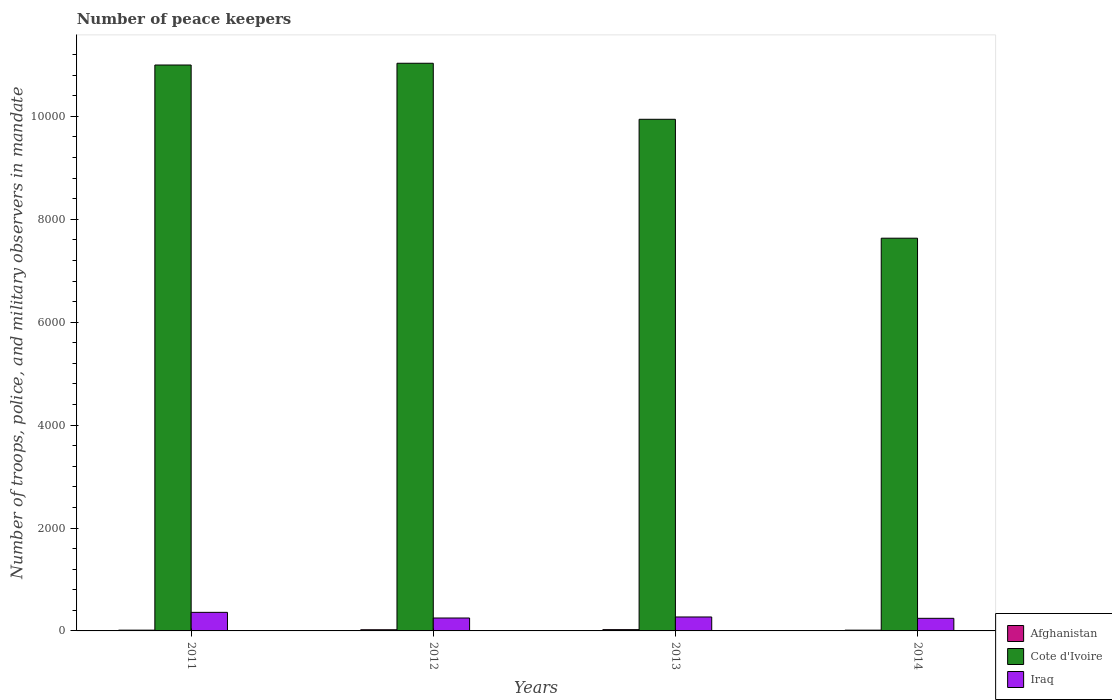How many different coloured bars are there?
Provide a succinct answer. 3. Are the number of bars per tick equal to the number of legend labels?
Your response must be concise. Yes. How many bars are there on the 3rd tick from the left?
Give a very brief answer. 3. How many bars are there on the 3rd tick from the right?
Give a very brief answer. 3. What is the number of peace keepers in in Cote d'Ivoire in 2012?
Make the answer very short. 1.10e+04. Across all years, what is the maximum number of peace keepers in in Afghanistan?
Provide a short and direct response. 25. Across all years, what is the minimum number of peace keepers in in Cote d'Ivoire?
Offer a very short reply. 7633. In which year was the number of peace keepers in in Iraq minimum?
Make the answer very short. 2014. What is the total number of peace keepers in in Cote d'Ivoire in the graph?
Offer a very short reply. 3.96e+04. What is the difference between the number of peace keepers in in Afghanistan in 2011 and that in 2012?
Give a very brief answer. -8. What is the difference between the number of peace keepers in in Afghanistan in 2011 and the number of peace keepers in in Iraq in 2013?
Your response must be concise. -256. In the year 2013, what is the difference between the number of peace keepers in in Iraq and number of peace keepers in in Afghanistan?
Offer a terse response. 246. What is the ratio of the number of peace keepers in in Cote d'Ivoire in 2011 to that in 2012?
Your answer should be very brief. 1. Is the number of peace keepers in in Cote d'Ivoire in 2013 less than that in 2014?
Keep it short and to the point. No. What is the difference between the highest and the second highest number of peace keepers in in Iraq?
Keep it short and to the point. 90. In how many years, is the number of peace keepers in in Cote d'Ivoire greater than the average number of peace keepers in in Cote d'Ivoire taken over all years?
Ensure brevity in your answer.  3. What does the 3rd bar from the left in 2013 represents?
Offer a very short reply. Iraq. What does the 2nd bar from the right in 2011 represents?
Offer a terse response. Cote d'Ivoire. Are all the bars in the graph horizontal?
Your answer should be very brief. No. Are the values on the major ticks of Y-axis written in scientific E-notation?
Keep it short and to the point. No. Does the graph contain any zero values?
Make the answer very short. No. Does the graph contain grids?
Your answer should be compact. No. How many legend labels are there?
Offer a terse response. 3. How are the legend labels stacked?
Ensure brevity in your answer.  Vertical. What is the title of the graph?
Ensure brevity in your answer.  Number of peace keepers. What is the label or title of the X-axis?
Keep it short and to the point. Years. What is the label or title of the Y-axis?
Make the answer very short. Number of troops, police, and military observers in mandate. What is the Number of troops, police, and military observers in mandate of Afghanistan in 2011?
Your answer should be very brief. 15. What is the Number of troops, police, and military observers in mandate in Cote d'Ivoire in 2011?
Provide a succinct answer. 1.10e+04. What is the Number of troops, police, and military observers in mandate of Iraq in 2011?
Give a very brief answer. 361. What is the Number of troops, police, and military observers in mandate of Cote d'Ivoire in 2012?
Offer a terse response. 1.10e+04. What is the Number of troops, police, and military observers in mandate in Iraq in 2012?
Give a very brief answer. 251. What is the Number of troops, police, and military observers in mandate in Cote d'Ivoire in 2013?
Offer a very short reply. 9944. What is the Number of troops, police, and military observers in mandate of Iraq in 2013?
Offer a very short reply. 271. What is the Number of troops, police, and military observers in mandate of Cote d'Ivoire in 2014?
Give a very brief answer. 7633. What is the Number of troops, police, and military observers in mandate of Iraq in 2014?
Your answer should be compact. 245. Across all years, what is the maximum Number of troops, police, and military observers in mandate of Cote d'Ivoire?
Offer a very short reply. 1.10e+04. Across all years, what is the maximum Number of troops, police, and military observers in mandate in Iraq?
Your answer should be very brief. 361. Across all years, what is the minimum Number of troops, police, and military observers in mandate of Afghanistan?
Make the answer very short. 15. Across all years, what is the minimum Number of troops, police, and military observers in mandate in Cote d'Ivoire?
Your response must be concise. 7633. Across all years, what is the minimum Number of troops, police, and military observers in mandate of Iraq?
Your answer should be compact. 245. What is the total Number of troops, police, and military observers in mandate of Cote d'Ivoire in the graph?
Ensure brevity in your answer.  3.96e+04. What is the total Number of troops, police, and military observers in mandate in Iraq in the graph?
Offer a terse response. 1128. What is the difference between the Number of troops, police, and military observers in mandate in Afghanistan in 2011 and that in 2012?
Make the answer very short. -8. What is the difference between the Number of troops, police, and military observers in mandate in Cote d'Ivoire in 2011 and that in 2012?
Your answer should be compact. -34. What is the difference between the Number of troops, police, and military observers in mandate of Iraq in 2011 and that in 2012?
Keep it short and to the point. 110. What is the difference between the Number of troops, police, and military observers in mandate in Cote d'Ivoire in 2011 and that in 2013?
Keep it short and to the point. 1055. What is the difference between the Number of troops, police, and military observers in mandate in Cote d'Ivoire in 2011 and that in 2014?
Provide a short and direct response. 3366. What is the difference between the Number of troops, police, and military observers in mandate in Iraq in 2011 and that in 2014?
Your answer should be very brief. 116. What is the difference between the Number of troops, police, and military observers in mandate of Afghanistan in 2012 and that in 2013?
Offer a very short reply. -2. What is the difference between the Number of troops, police, and military observers in mandate in Cote d'Ivoire in 2012 and that in 2013?
Offer a terse response. 1089. What is the difference between the Number of troops, police, and military observers in mandate of Afghanistan in 2012 and that in 2014?
Ensure brevity in your answer.  8. What is the difference between the Number of troops, police, and military observers in mandate of Cote d'Ivoire in 2012 and that in 2014?
Provide a short and direct response. 3400. What is the difference between the Number of troops, police, and military observers in mandate of Iraq in 2012 and that in 2014?
Provide a succinct answer. 6. What is the difference between the Number of troops, police, and military observers in mandate in Afghanistan in 2013 and that in 2014?
Your answer should be very brief. 10. What is the difference between the Number of troops, police, and military observers in mandate in Cote d'Ivoire in 2013 and that in 2014?
Ensure brevity in your answer.  2311. What is the difference between the Number of troops, police, and military observers in mandate of Iraq in 2013 and that in 2014?
Make the answer very short. 26. What is the difference between the Number of troops, police, and military observers in mandate of Afghanistan in 2011 and the Number of troops, police, and military observers in mandate of Cote d'Ivoire in 2012?
Your response must be concise. -1.10e+04. What is the difference between the Number of troops, police, and military observers in mandate in Afghanistan in 2011 and the Number of troops, police, and military observers in mandate in Iraq in 2012?
Keep it short and to the point. -236. What is the difference between the Number of troops, police, and military observers in mandate of Cote d'Ivoire in 2011 and the Number of troops, police, and military observers in mandate of Iraq in 2012?
Your answer should be compact. 1.07e+04. What is the difference between the Number of troops, police, and military observers in mandate in Afghanistan in 2011 and the Number of troops, police, and military observers in mandate in Cote d'Ivoire in 2013?
Make the answer very short. -9929. What is the difference between the Number of troops, police, and military observers in mandate of Afghanistan in 2011 and the Number of troops, police, and military observers in mandate of Iraq in 2013?
Keep it short and to the point. -256. What is the difference between the Number of troops, police, and military observers in mandate in Cote d'Ivoire in 2011 and the Number of troops, police, and military observers in mandate in Iraq in 2013?
Make the answer very short. 1.07e+04. What is the difference between the Number of troops, police, and military observers in mandate in Afghanistan in 2011 and the Number of troops, police, and military observers in mandate in Cote d'Ivoire in 2014?
Your response must be concise. -7618. What is the difference between the Number of troops, police, and military observers in mandate in Afghanistan in 2011 and the Number of troops, police, and military observers in mandate in Iraq in 2014?
Your answer should be very brief. -230. What is the difference between the Number of troops, police, and military observers in mandate of Cote d'Ivoire in 2011 and the Number of troops, police, and military observers in mandate of Iraq in 2014?
Give a very brief answer. 1.08e+04. What is the difference between the Number of troops, police, and military observers in mandate in Afghanistan in 2012 and the Number of troops, police, and military observers in mandate in Cote d'Ivoire in 2013?
Ensure brevity in your answer.  -9921. What is the difference between the Number of troops, police, and military observers in mandate of Afghanistan in 2012 and the Number of troops, police, and military observers in mandate of Iraq in 2013?
Keep it short and to the point. -248. What is the difference between the Number of troops, police, and military observers in mandate of Cote d'Ivoire in 2012 and the Number of troops, police, and military observers in mandate of Iraq in 2013?
Ensure brevity in your answer.  1.08e+04. What is the difference between the Number of troops, police, and military observers in mandate in Afghanistan in 2012 and the Number of troops, police, and military observers in mandate in Cote d'Ivoire in 2014?
Offer a terse response. -7610. What is the difference between the Number of troops, police, and military observers in mandate of Afghanistan in 2012 and the Number of troops, police, and military observers in mandate of Iraq in 2014?
Make the answer very short. -222. What is the difference between the Number of troops, police, and military observers in mandate of Cote d'Ivoire in 2012 and the Number of troops, police, and military observers in mandate of Iraq in 2014?
Make the answer very short. 1.08e+04. What is the difference between the Number of troops, police, and military observers in mandate in Afghanistan in 2013 and the Number of troops, police, and military observers in mandate in Cote d'Ivoire in 2014?
Offer a very short reply. -7608. What is the difference between the Number of troops, police, and military observers in mandate in Afghanistan in 2013 and the Number of troops, police, and military observers in mandate in Iraq in 2014?
Provide a succinct answer. -220. What is the difference between the Number of troops, police, and military observers in mandate in Cote d'Ivoire in 2013 and the Number of troops, police, and military observers in mandate in Iraq in 2014?
Offer a very short reply. 9699. What is the average Number of troops, police, and military observers in mandate of Afghanistan per year?
Provide a short and direct response. 19.5. What is the average Number of troops, police, and military observers in mandate of Cote d'Ivoire per year?
Give a very brief answer. 9902.25. What is the average Number of troops, police, and military observers in mandate of Iraq per year?
Ensure brevity in your answer.  282. In the year 2011, what is the difference between the Number of troops, police, and military observers in mandate in Afghanistan and Number of troops, police, and military observers in mandate in Cote d'Ivoire?
Offer a terse response. -1.10e+04. In the year 2011, what is the difference between the Number of troops, police, and military observers in mandate of Afghanistan and Number of troops, police, and military observers in mandate of Iraq?
Give a very brief answer. -346. In the year 2011, what is the difference between the Number of troops, police, and military observers in mandate of Cote d'Ivoire and Number of troops, police, and military observers in mandate of Iraq?
Your response must be concise. 1.06e+04. In the year 2012, what is the difference between the Number of troops, police, and military observers in mandate of Afghanistan and Number of troops, police, and military observers in mandate of Cote d'Ivoire?
Offer a very short reply. -1.10e+04. In the year 2012, what is the difference between the Number of troops, police, and military observers in mandate in Afghanistan and Number of troops, police, and military observers in mandate in Iraq?
Provide a succinct answer. -228. In the year 2012, what is the difference between the Number of troops, police, and military observers in mandate in Cote d'Ivoire and Number of troops, police, and military observers in mandate in Iraq?
Give a very brief answer. 1.08e+04. In the year 2013, what is the difference between the Number of troops, police, and military observers in mandate of Afghanistan and Number of troops, police, and military observers in mandate of Cote d'Ivoire?
Your answer should be very brief. -9919. In the year 2013, what is the difference between the Number of troops, police, and military observers in mandate in Afghanistan and Number of troops, police, and military observers in mandate in Iraq?
Your answer should be very brief. -246. In the year 2013, what is the difference between the Number of troops, police, and military observers in mandate in Cote d'Ivoire and Number of troops, police, and military observers in mandate in Iraq?
Offer a very short reply. 9673. In the year 2014, what is the difference between the Number of troops, police, and military observers in mandate of Afghanistan and Number of troops, police, and military observers in mandate of Cote d'Ivoire?
Your response must be concise. -7618. In the year 2014, what is the difference between the Number of troops, police, and military observers in mandate of Afghanistan and Number of troops, police, and military observers in mandate of Iraq?
Ensure brevity in your answer.  -230. In the year 2014, what is the difference between the Number of troops, police, and military observers in mandate in Cote d'Ivoire and Number of troops, police, and military observers in mandate in Iraq?
Make the answer very short. 7388. What is the ratio of the Number of troops, police, and military observers in mandate of Afghanistan in 2011 to that in 2012?
Your answer should be very brief. 0.65. What is the ratio of the Number of troops, police, and military observers in mandate of Cote d'Ivoire in 2011 to that in 2012?
Make the answer very short. 1. What is the ratio of the Number of troops, police, and military observers in mandate in Iraq in 2011 to that in 2012?
Provide a succinct answer. 1.44. What is the ratio of the Number of troops, police, and military observers in mandate in Cote d'Ivoire in 2011 to that in 2013?
Provide a succinct answer. 1.11. What is the ratio of the Number of troops, police, and military observers in mandate of Iraq in 2011 to that in 2013?
Give a very brief answer. 1.33. What is the ratio of the Number of troops, police, and military observers in mandate in Afghanistan in 2011 to that in 2014?
Offer a terse response. 1. What is the ratio of the Number of troops, police, and military observers in mandate in Cote d'Ivoire in 2011 to that in 2014?
Your response must be concise. 1.44. What is the ratio of the Number of troops, police, and military observers in mandate of Iraq in 2011 to that in 2014?
Provide a short and direct response. 1.47. What is the ratio of the Number of troops, police, and military observers in mandate in Afghanistan in 2012 to that in 2013?
Provide a short and direct response. 0.92. What is the ratio of the Number of troops, police, and military observers in mandate in Cote d'Ivoire in 2012 to that in 2013?
Offer a terse response. 1.11. What is the ratio of the Number of troops, police, and military observers in mandate of Iraq in 2012 to that in 2013?
Give a very brief answer. 0.93. What is the ratio of the Number of troops, police, and military observers in mandate of Afghanistan in 2012 to that in 2014?
Provide a short and direct response. 1.53. What is the ratio of the Number of troops, police, and military observers in mandate of Cote d'Ivoire in 2012 to that in 2014?
Keep it short and to the point. 1.45. What is the ratio of the Number of troops, police, and military observers in mandate of Iraq in 2012 to that in 2014?
Give a very brief answer. 1.02. What is the ratio of the Number of troops, police, and military observers in mandate of Afghanistan in 2013 to that in 2014?
Provide a succinct answer. 1.67. What is the ratio of the Number of troops, police, and military observers in mandate of Cote d'Ivoire in 2013 to that in 2014?
Offer a very short reply. 1.3. What is the ratio of the Number of troops, police, and military observers in mandate of Iraq in 2013 to that in 2014?
Your response must be concise. 1.11. What is the difference between the highest and the second highest Number of troops, police, and military observers in mandate of Cote d'Ivoire?
Offer a terse response. 34. What is the difference between the highest and the second highest Number of troops, police, and military observers in mandate of Iraq?
Make the answer very short. 90. What is the difference between the highest and the lowest Number of troops, police, and military observers in mandate in Cote d'Ivoire?
Your answer should be compact. 3400. What is the difference between the highest and the lowest Number of troops, police, and military observers in mandate of Iraq?
Provide a short and direct response. 116. 